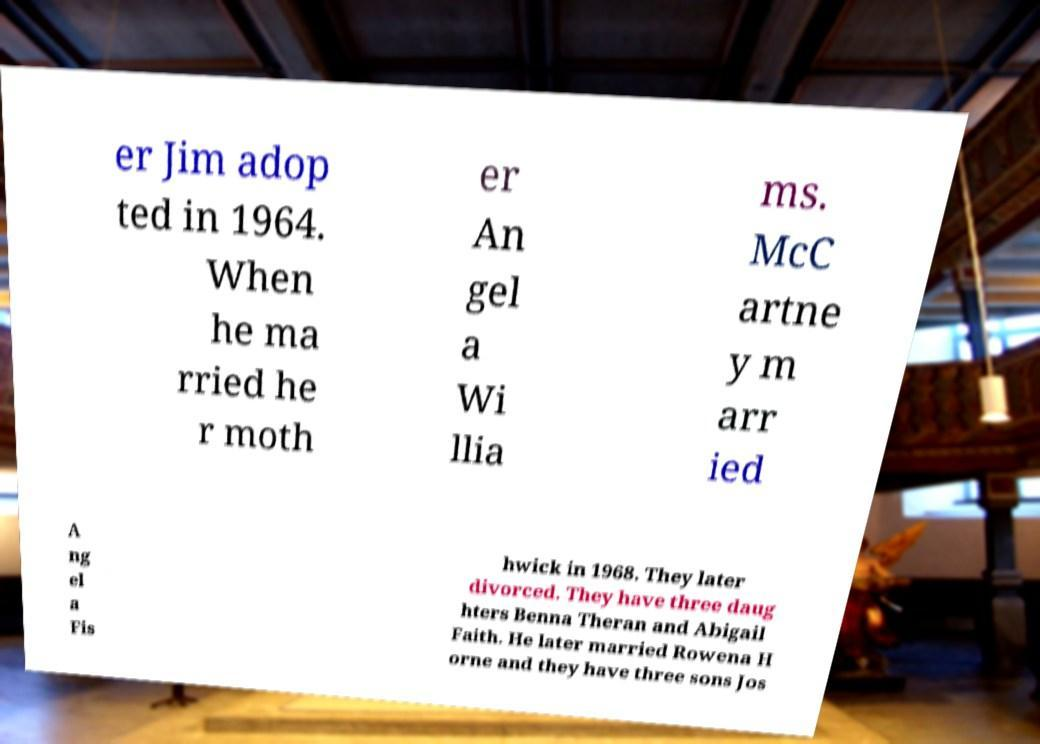I need the written content from this picture converted into text. Can you do that? er Jim adop ted in 1964. When he ma rried he r moth er An gel a Wi llia ms. McC artne y m arr ied A ng el a Fis hwick in 1968. They later divorced. They have three daug hters Benna Theran and Abigail Faith. He later married Rowena H orne and they have three sons Jos 